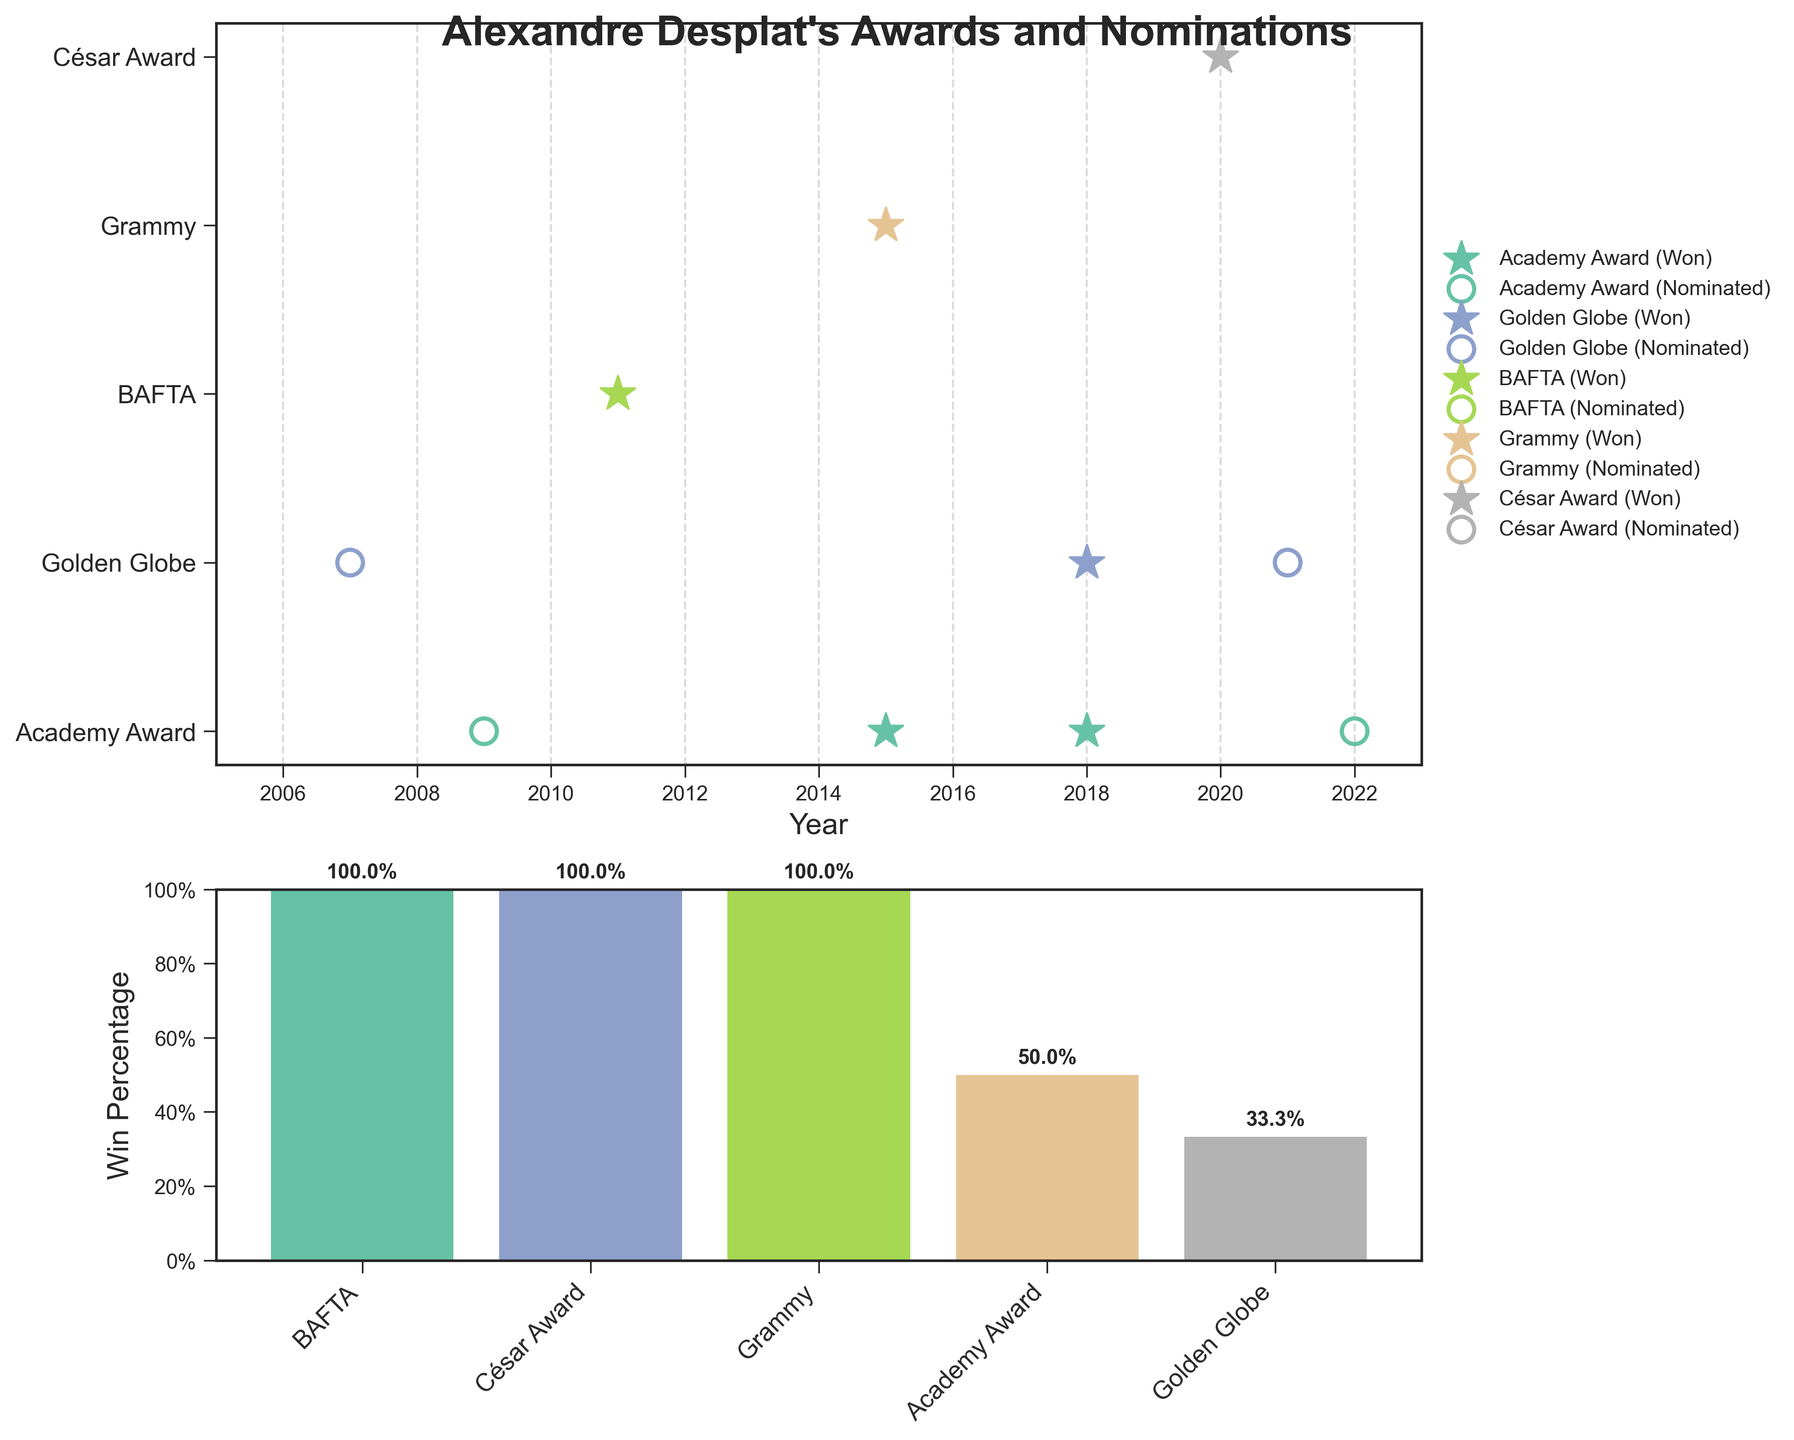Which award did Alexandre Desplat win in 2015? Look at the "Awards Timeline" plot and focus on the star markers for the year 2015, it indicates a win for the Academy Award
Answer: Academy Award How many times was Alexandre Desplat nominated for a Golden Globe? Observe the "Awards Timeline" plot and count the 'o' (circle) markers corresponding to the Golden Globe category
Answer: 3 What is the proportion of BAFTA Awards won by Alexandre Desplat? In the "Win/Nomination Ratio" plot, identify the BAFTA bar and read its win percentage close to the marker
Answer: 50% Which years did Alexandre Desplat win an Academy Award for Best Original Score? Look at the "Awards Timeline" plot and locate all star markers for Academy Award, the years marked are 2015 and 2018
Answer: 2015 and 2018 How many awards did Alexandre Desplat win in 2018? Notice all the star markers in the "Awards Timeline" plot for the year 2018, there are 2 stars which means he won 2 awards
Answer: 2 How does the win percentage for Grammy Awards compare to the César Awards? Compare the heights of the bars for Grammy and César in the "Win/Nomination Ratio" plot, the Grammy bar is significantly shorter than César
Answer: César Awards have a higher win percentage Which award has the highest win percentage for Alexandre Desplat? From the "Win/Nomination Ratio" plot, identify the tallest bar, which corresponds to the César Award
Answer: César Award Between 2007 and 2022, for which awards did Alexandre Desplat receive nominations but not wins? Refer to the circle ('o') markers in the "Awards Timeline" plot without a corresponding star marker, these are the Golden Globe in 2007 and 2021, and Academy Awards in 2009 and 2022
Answer: Golden Globe (2007, 2021) and Academy Award (2009, 2022) 